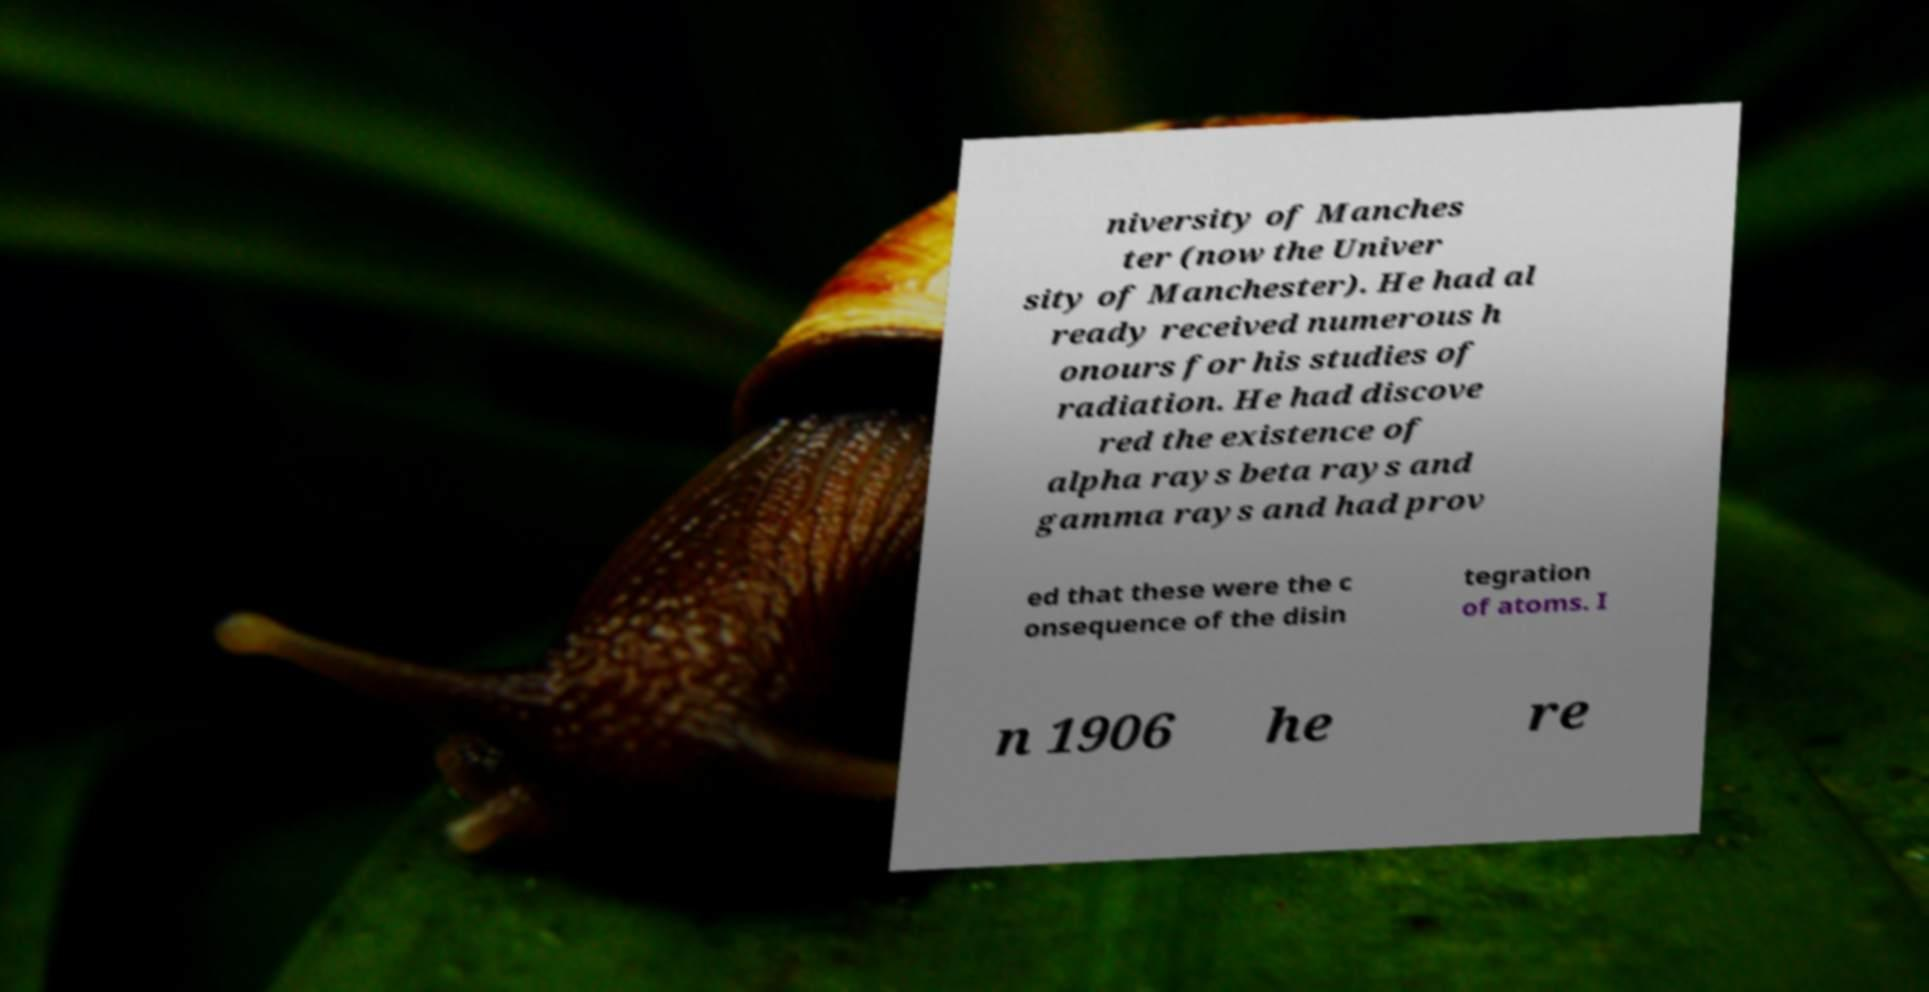For documentation purposes, I need the text within this image transcribed. Could you provide that? niversity of Manches ter (now the Univer sity of Manchester). He had al ready received numerous h onours for his studies of radiation. He had discove red the existence of alpha rays beta rays and gamma rays and had prov ed that these were the c onsequence of the disin tegration of atoms. I n 1906 he re 